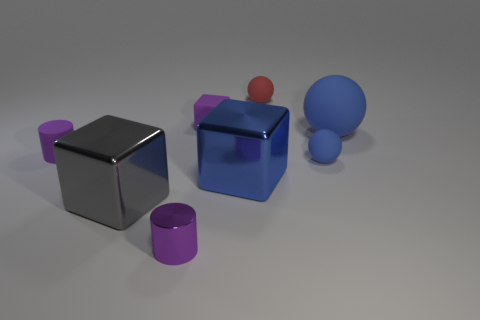Subtract all small balls. How many balls are left? 1 Add 1 large red shiny cylinders. How many objects exist? 9 Subtract all cylinders. How many objects are left? 6 Subtract 2 blocks. How many blocks are left? 1 Subtract all cyan blocks. Subtract all purple spheres. How many blocks are left? 3 Subtract all green cylinders. How many red balls are left? 1 Subtract all tiny cylinders. Subtract all red objects. How many objects are left? 5 Add 5 red balls. How many red balls are left? 6 Add 1 blue metal cubes. How many blue metal cubes exist? 2 Subtract all blue blocks. How many blocks are left? 2 